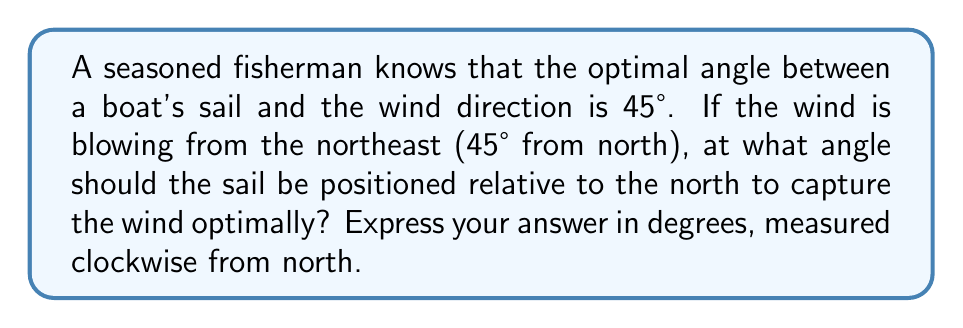Provide a solution to this math problem. Let's approach this step-by-step:

1) First, we need to understand the given information:
   - The optimal angle between the sail and the wind is 45°
   - The wind is blowing from the northeast (45° from north)

2) We can visualize this situation:

   [asy]
   import geometry;
   
   size(200);
   
   draw((-100,0)--(100,0),arrow=Arrow(TeXHead));
   draw((0,-100)--(0,100),arrow=Arrow(TeXHead));
   
   label("N", (0,100), N);
   label("E", (100,0), E);
   
   draw((0,0)--(70,70),arrow=Arrow(TeXHead), blue);
   label("Wind", (35,35), NE, blue);
   
   draw((0,0)--(70,0),dashed);
   draw((70,0)--(70,70),dashed);
   
   draw((-50,-50)--(20,20), red);
   label("Sail", (-15,-15), SW, red);
   
   draw(arc((0,0),30,0,45), L=Label("45°", position=MidPoint));
   draw(arc((0,0),20,45,90), L=Label("45°", position=MidPoint));
   
   [/asy]

3) The wind direction is 45° from north. The sail should be at a 45° angle to the wind.

4) To find the sail's position, we add these two 45° angles:
   $$ 45° + 45° = 90° $$

5) Therefore, the sail should be positioned at 90° from north, which is due east.
Answer: 90° 